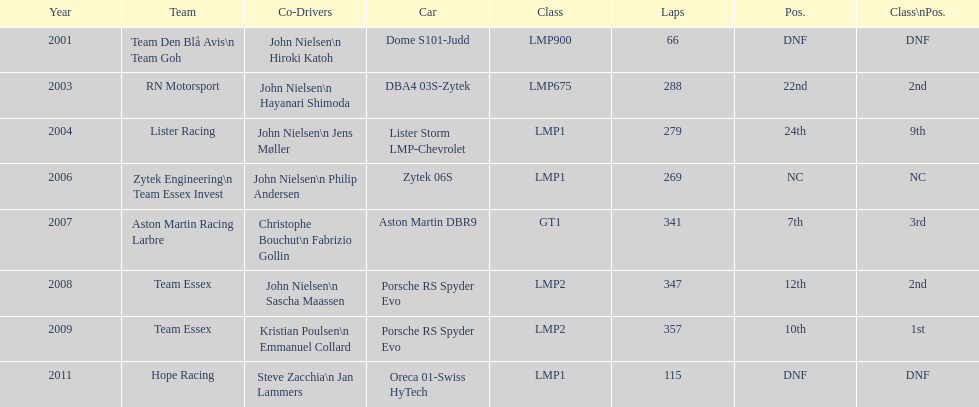For team lister in 2004, who was the co-driver alongside john nielsen? Jens Møller. 